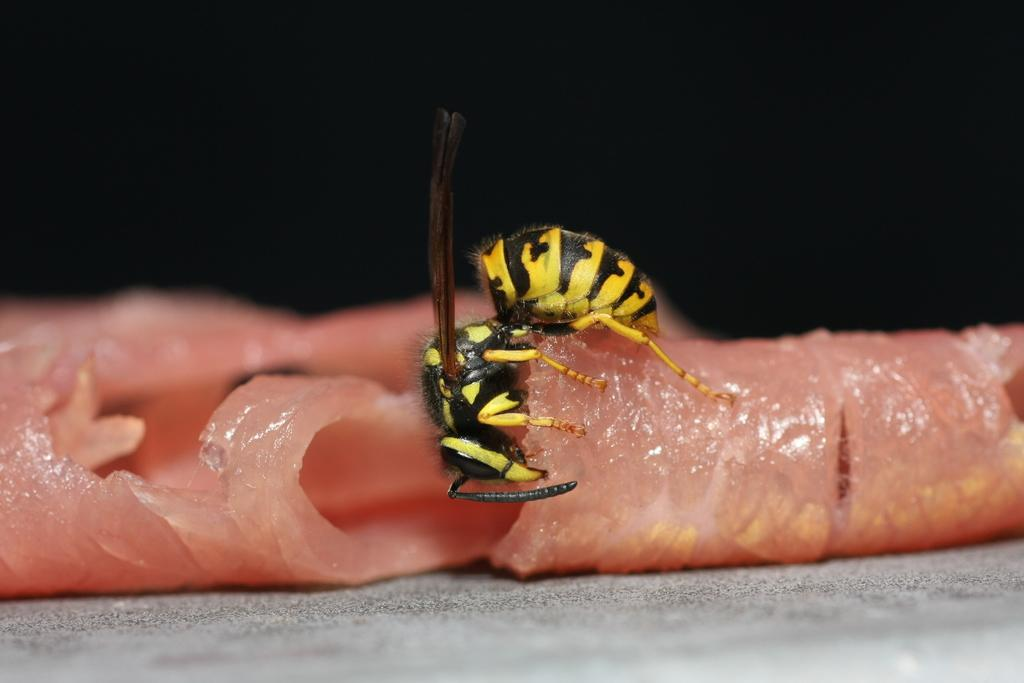What type of creature can be seen in the image? There is an insect in the image. What is the insect doing in the image? The insect is on meat. What colors are present on the insect? The insect has yellow and black coloring. What is the color of the background in the image? The background of the image is dark. Can you tell me how many lizards are balancing on the insect in the image? There are no lizards present in the image, and the insect is not balancing anything. 